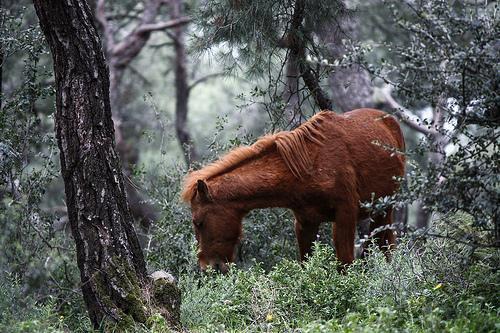How many horses are shown?
Give a very brief answer. 1. 